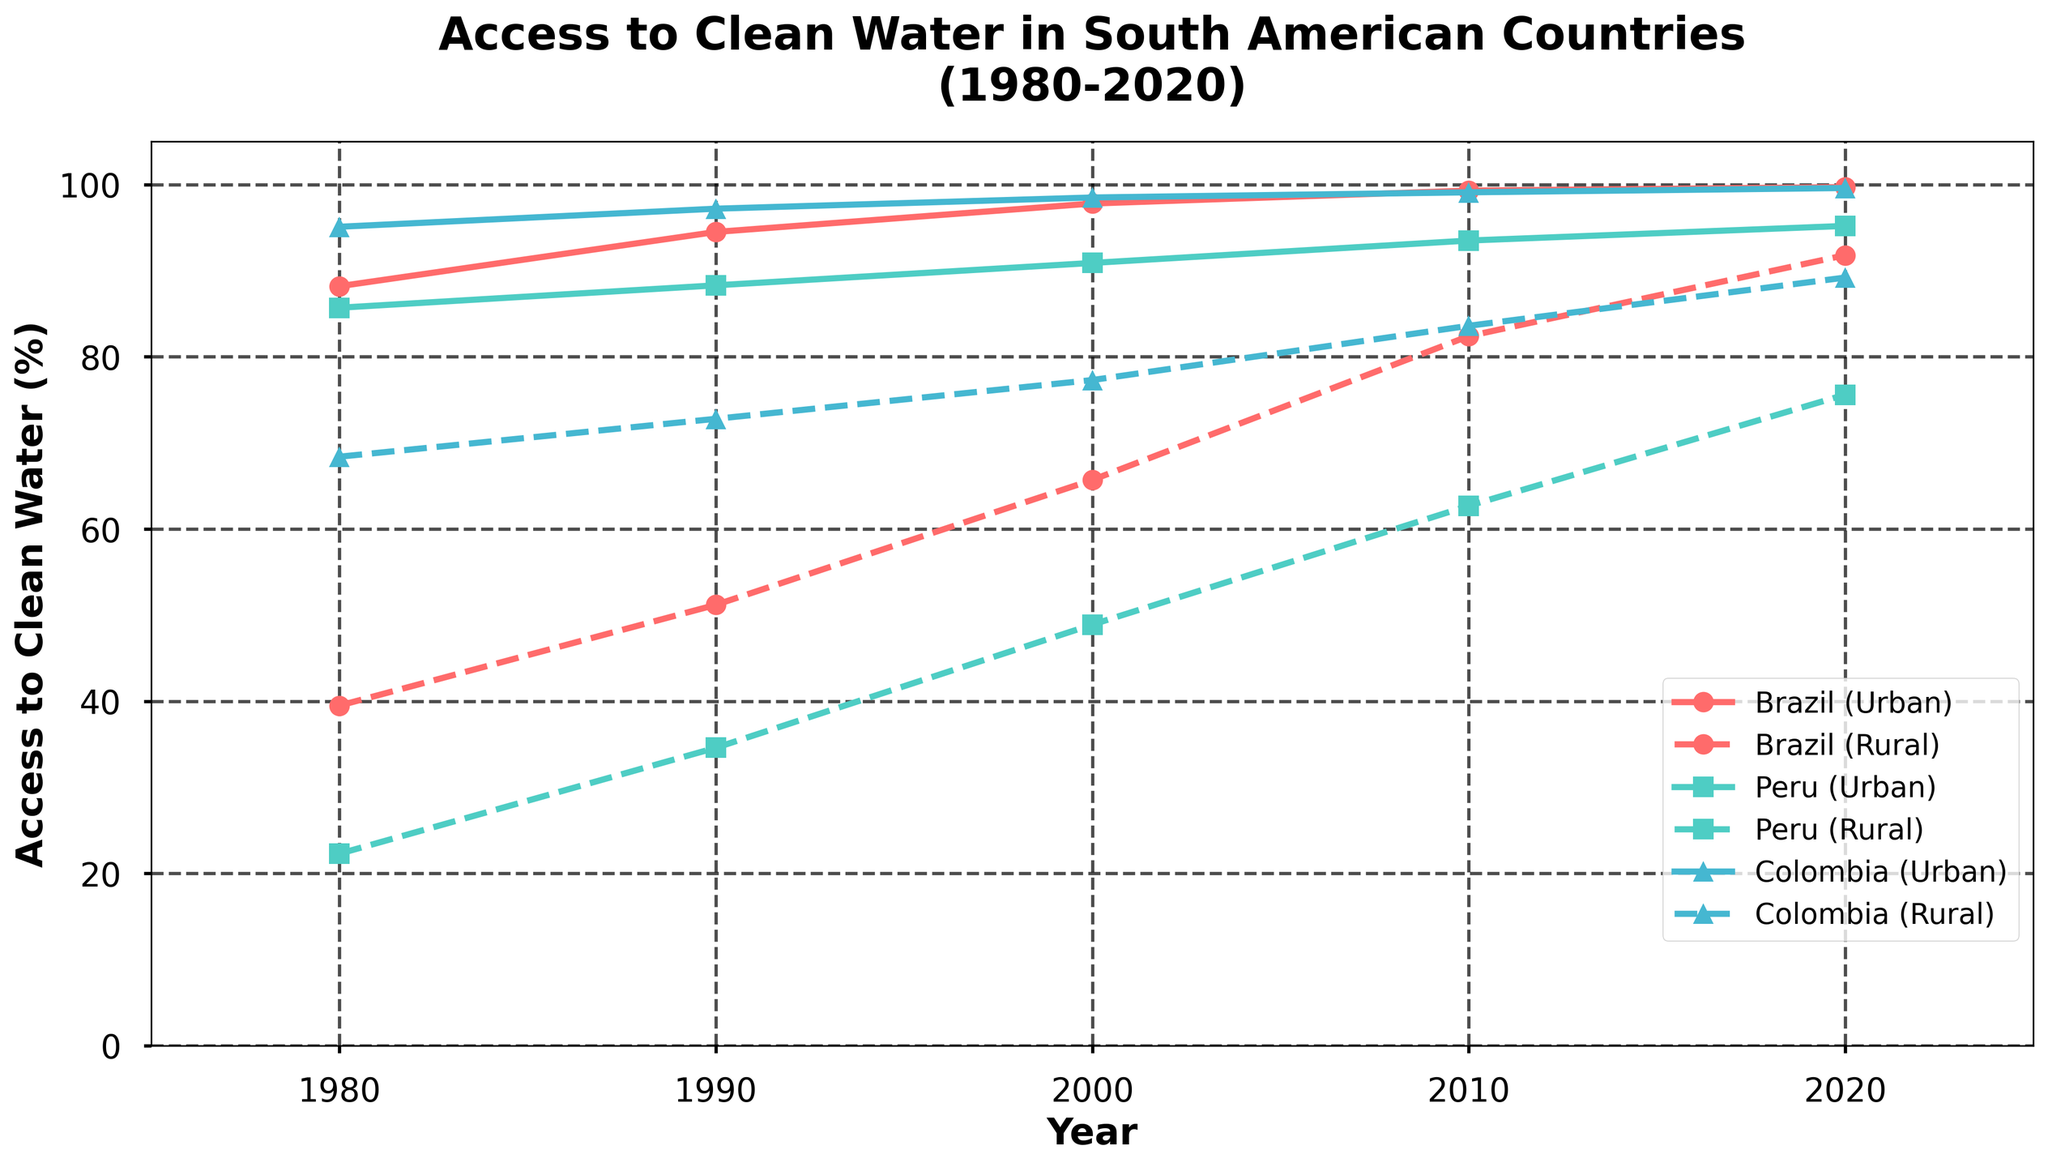Which country showed the most improvement in rural access to clean water between 1980 and 2020? By looking at the data for rural access to clean water in 1980 and comparing it to the data for 2020 for each country, we can compute the difference: Brazil: 91.8 - 39.5 = 52.3, Peru: 75.6 - 22.3 = 53.3, Colombia: 89.2 - 68.4 = 20.8. Thus, Peru showed the most improvement.
Answer: Peru Which country consistently had the highest urban access to clean water throughout the 40 years? By examining the lines representing urban access to clean water for the three countries, we can identify the country that always has the highest values. Colombia consistently had the highest urban access values compared to Brazil and Peru.
Answer: Colombia In 2010, how much higher was Brazil's urban access to clean water compared to Peru's rural access? We look at the values for Brazil’s urban access (99.3) and Peru’s rural access (62.7) in 2010. The difference is 99.3 - 62.7 = 36.6.
Answer: 36.6 What is the average increase in urban access to clean water in Brazil from 1980 to 2020? Calculate the difference between 2020 and 1980, then divide by the number of years: (99.7 - 88.2) / (2020 - 1980) = 11.5 / 40 = 0.2875 per year.
Answer: 0.2875 In what year did Colombia’s rural access to clean water reach over 80%? By looking at the trend line of Colombia’s rural access, we can find it went over 80% between 2000 and 2010, reaching 83.6% in 2010.
Answer: 2010 Which country had the smallest improvement in urban access to clean water from 1980 to 2020? Calculate the difference for each country: Brazil: 99.7 - 88.2 = 11.5, Peru: 95.2 - 85.7 = 9.5, Colombia: 99.6 - 95.1 = 4.5. Therefore, Colombia had the smallest improvement.
Answer: Colombia Compare urban and rural access to clean water in Peru in 2020. Which one is higher and by how much? Compare the values of urban (95.2) and rural (75.6) access to clean water in Peru for the year 2020: 95.2 - 75.6 = 19.6. Urban access is higher by 19.6.
Answer: Urban access, 19.6 How does the trend of rural access to clean water in Brazil compare to Colombia from 1980 to 2020? Compare the plotted lines for Brazil's and Colombia's rural access. We observe that both lines are increasing. However, Brazil starts lower and increases more steeply than Colombia, which starts higher and increases less steeply.
Answer: Brazil increases more steeply Which year did Brazil's rural access to clean water first surpass Peru's urban access to clean water? By examining the trends, we note Brazil's rural access surpasses Peru's urban access between 2010 and 2020, first occurring in 2010 when Brazil's rural access (82.4) surpasses Peru's urban access (93.5). Hence it happens in 2020.
Answer: 2020 